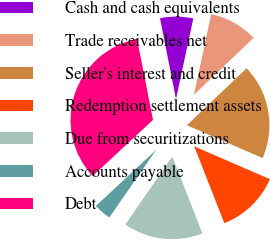Convert chart. <chart><loc_0><loc_0><loc_500><loc_500><pie_chart><fcel>Cash and cash equivalents<fcel>Trade receivables net<fcel>Seller's interest and credit<fcel>Redemption settlement assets<fcel>Due from securitizations<fcel>Accounts payable<fcel>Debt<nl><fcel>6.47%<fcel>9.51%<fcel>18.63%<fcel>12.55%<fcel>15.59%<fcel>3.43%<fcel>33.83%<nl></chart> 